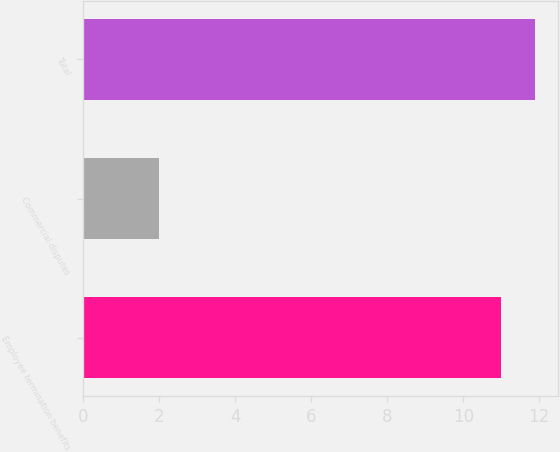Convert chart. <chart><loc_0><loc_0><loc_500><loc_500><bar_chart><fcel>Employee termination benefits<fcel>Commercial disputes<fcel>Total<nl><fcel>11<fcel>2<fcel>11.9<nl></chart> 